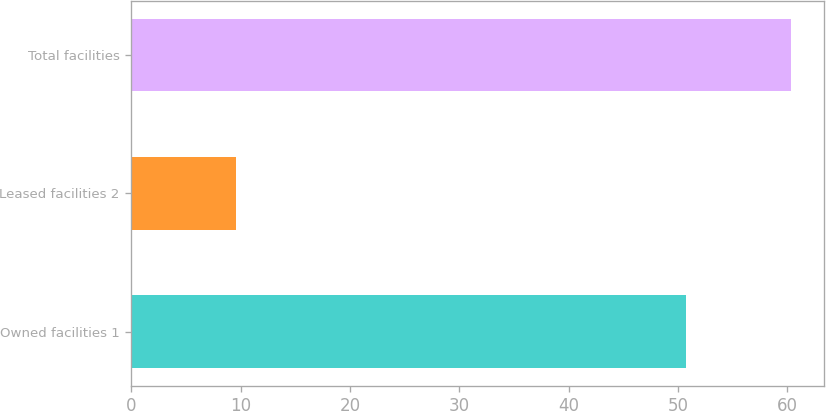Convert chart to OTSL. <chart><loc_0><loc_0><loc_500><loc_500><bar_chart><fcel>Owned facilities 1<fcel>Leased facilities 2<fcel>Total facilities<nl><fcel>50.7<fcel>9.6<fcel>60.3<nl></chart> 